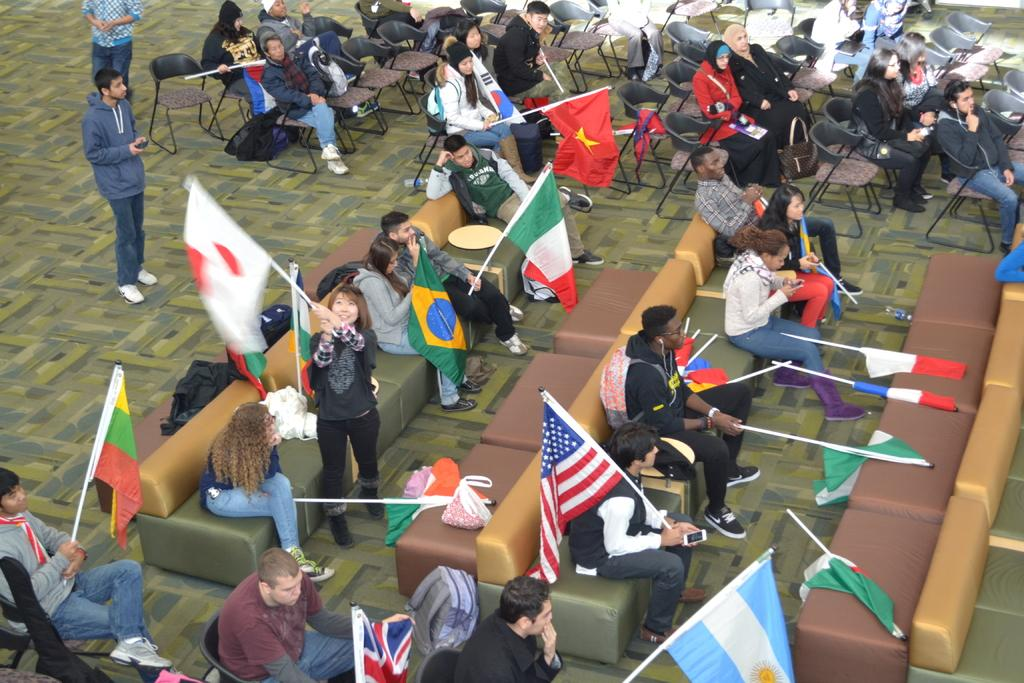What are the people in the image doing? The people in the image are sitting on chairs and sofas. What can be seen in the image besides the people? There are flags and bags in the image. What type of calendar is hanging on the wall in the image? There is no calendar visible in the image. What religion is being practiced in the image? There is no indication of any religious practice in the image. 